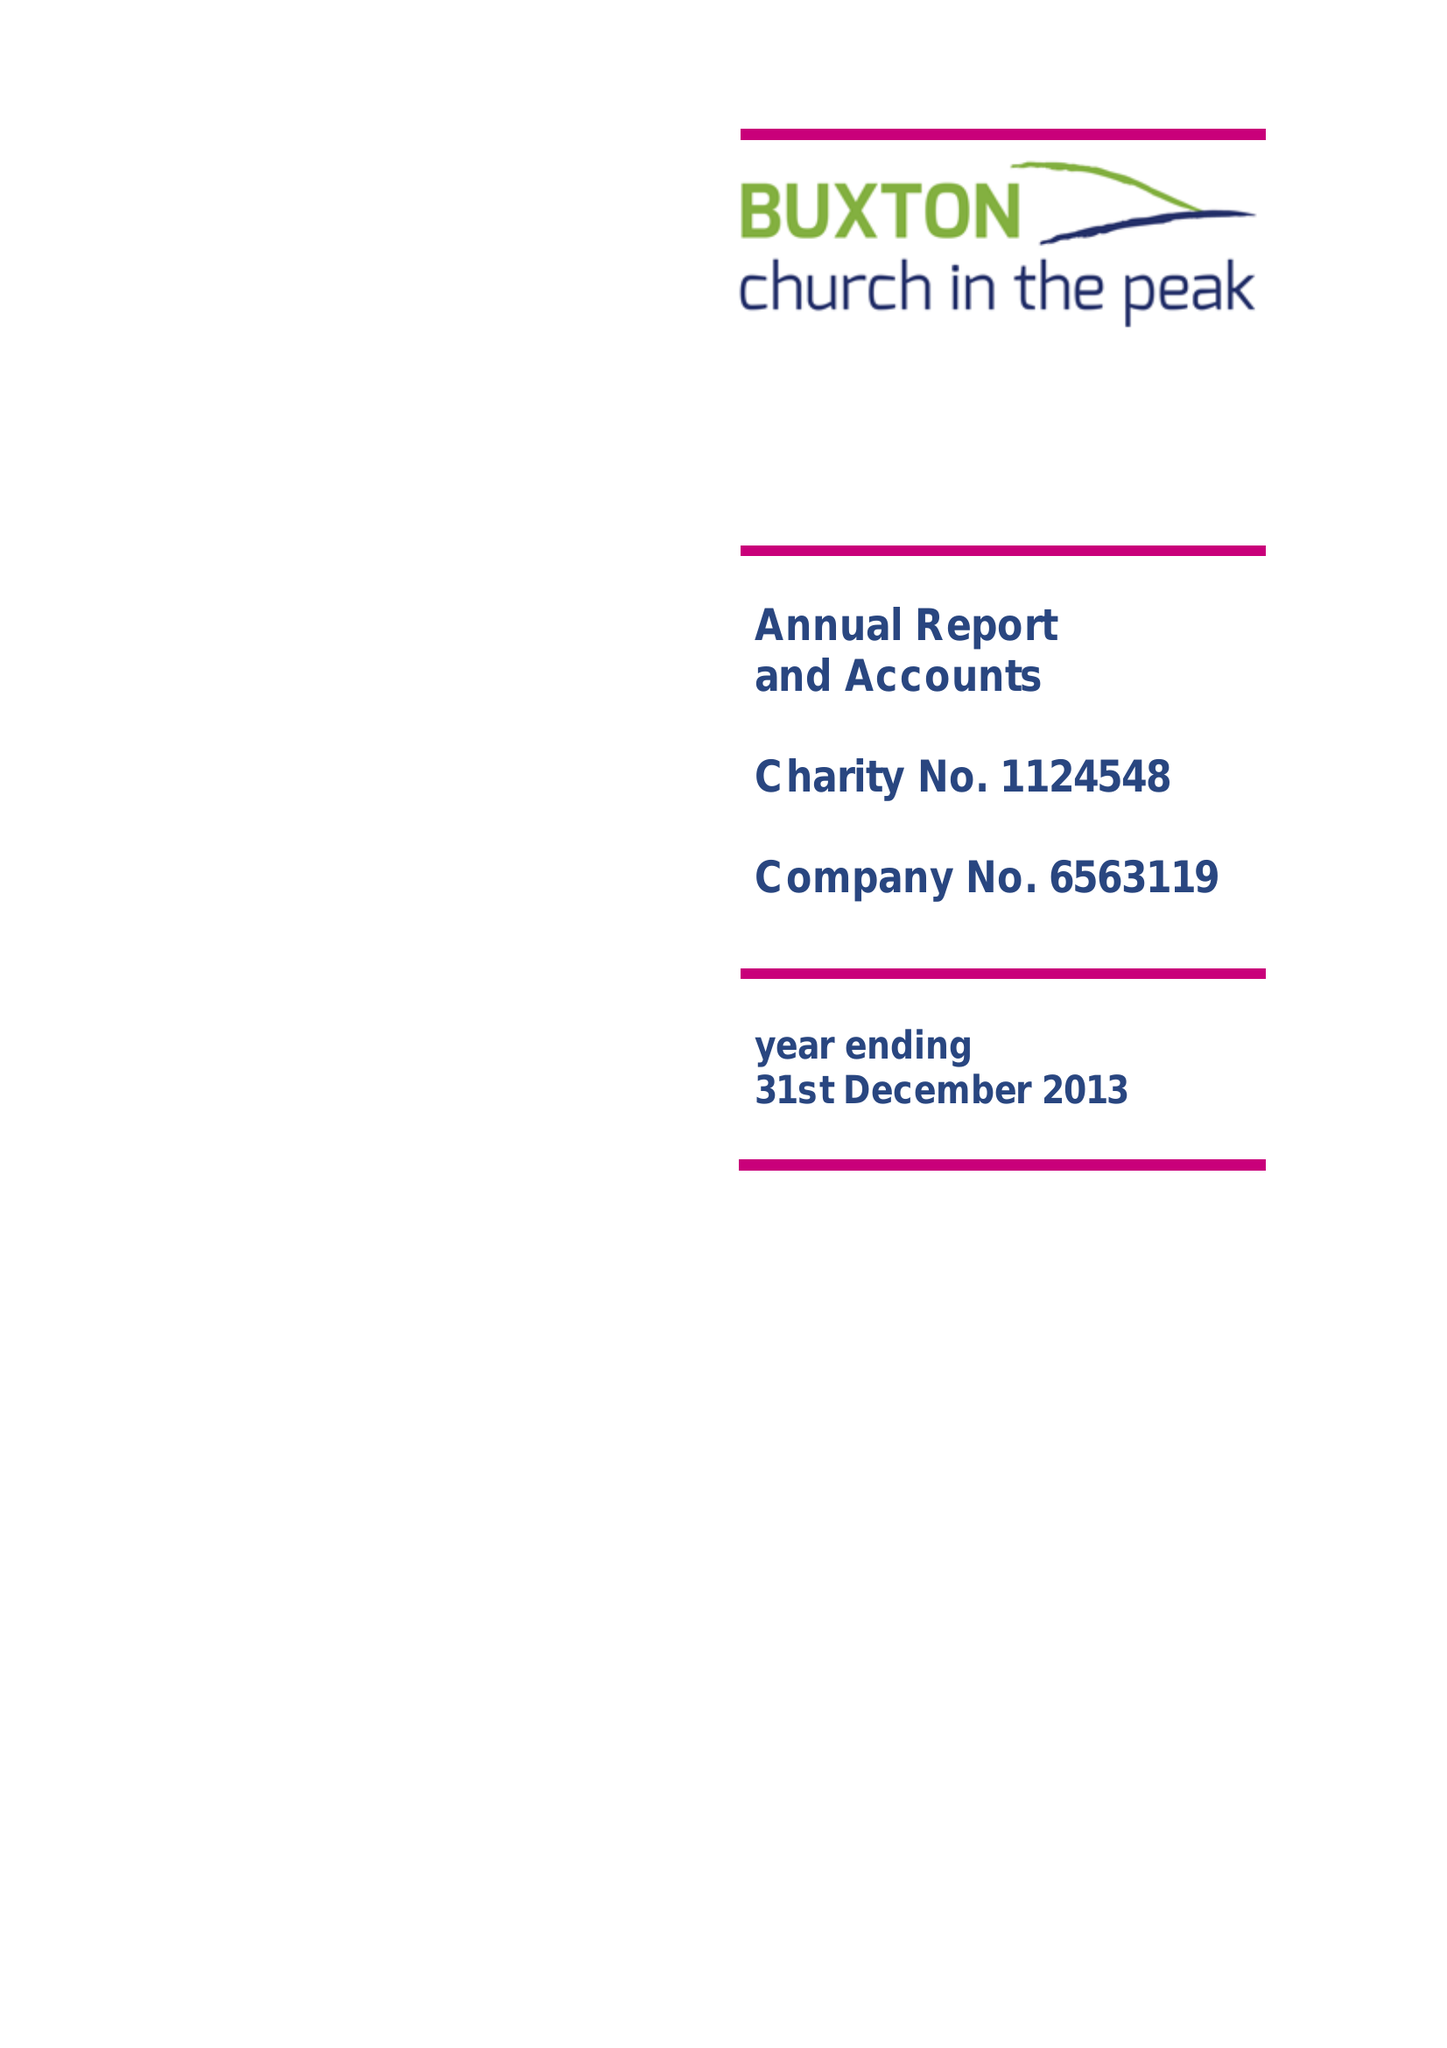What is the value for the address__post_town?
Answer the question using a single word or phrase. BUXTON 